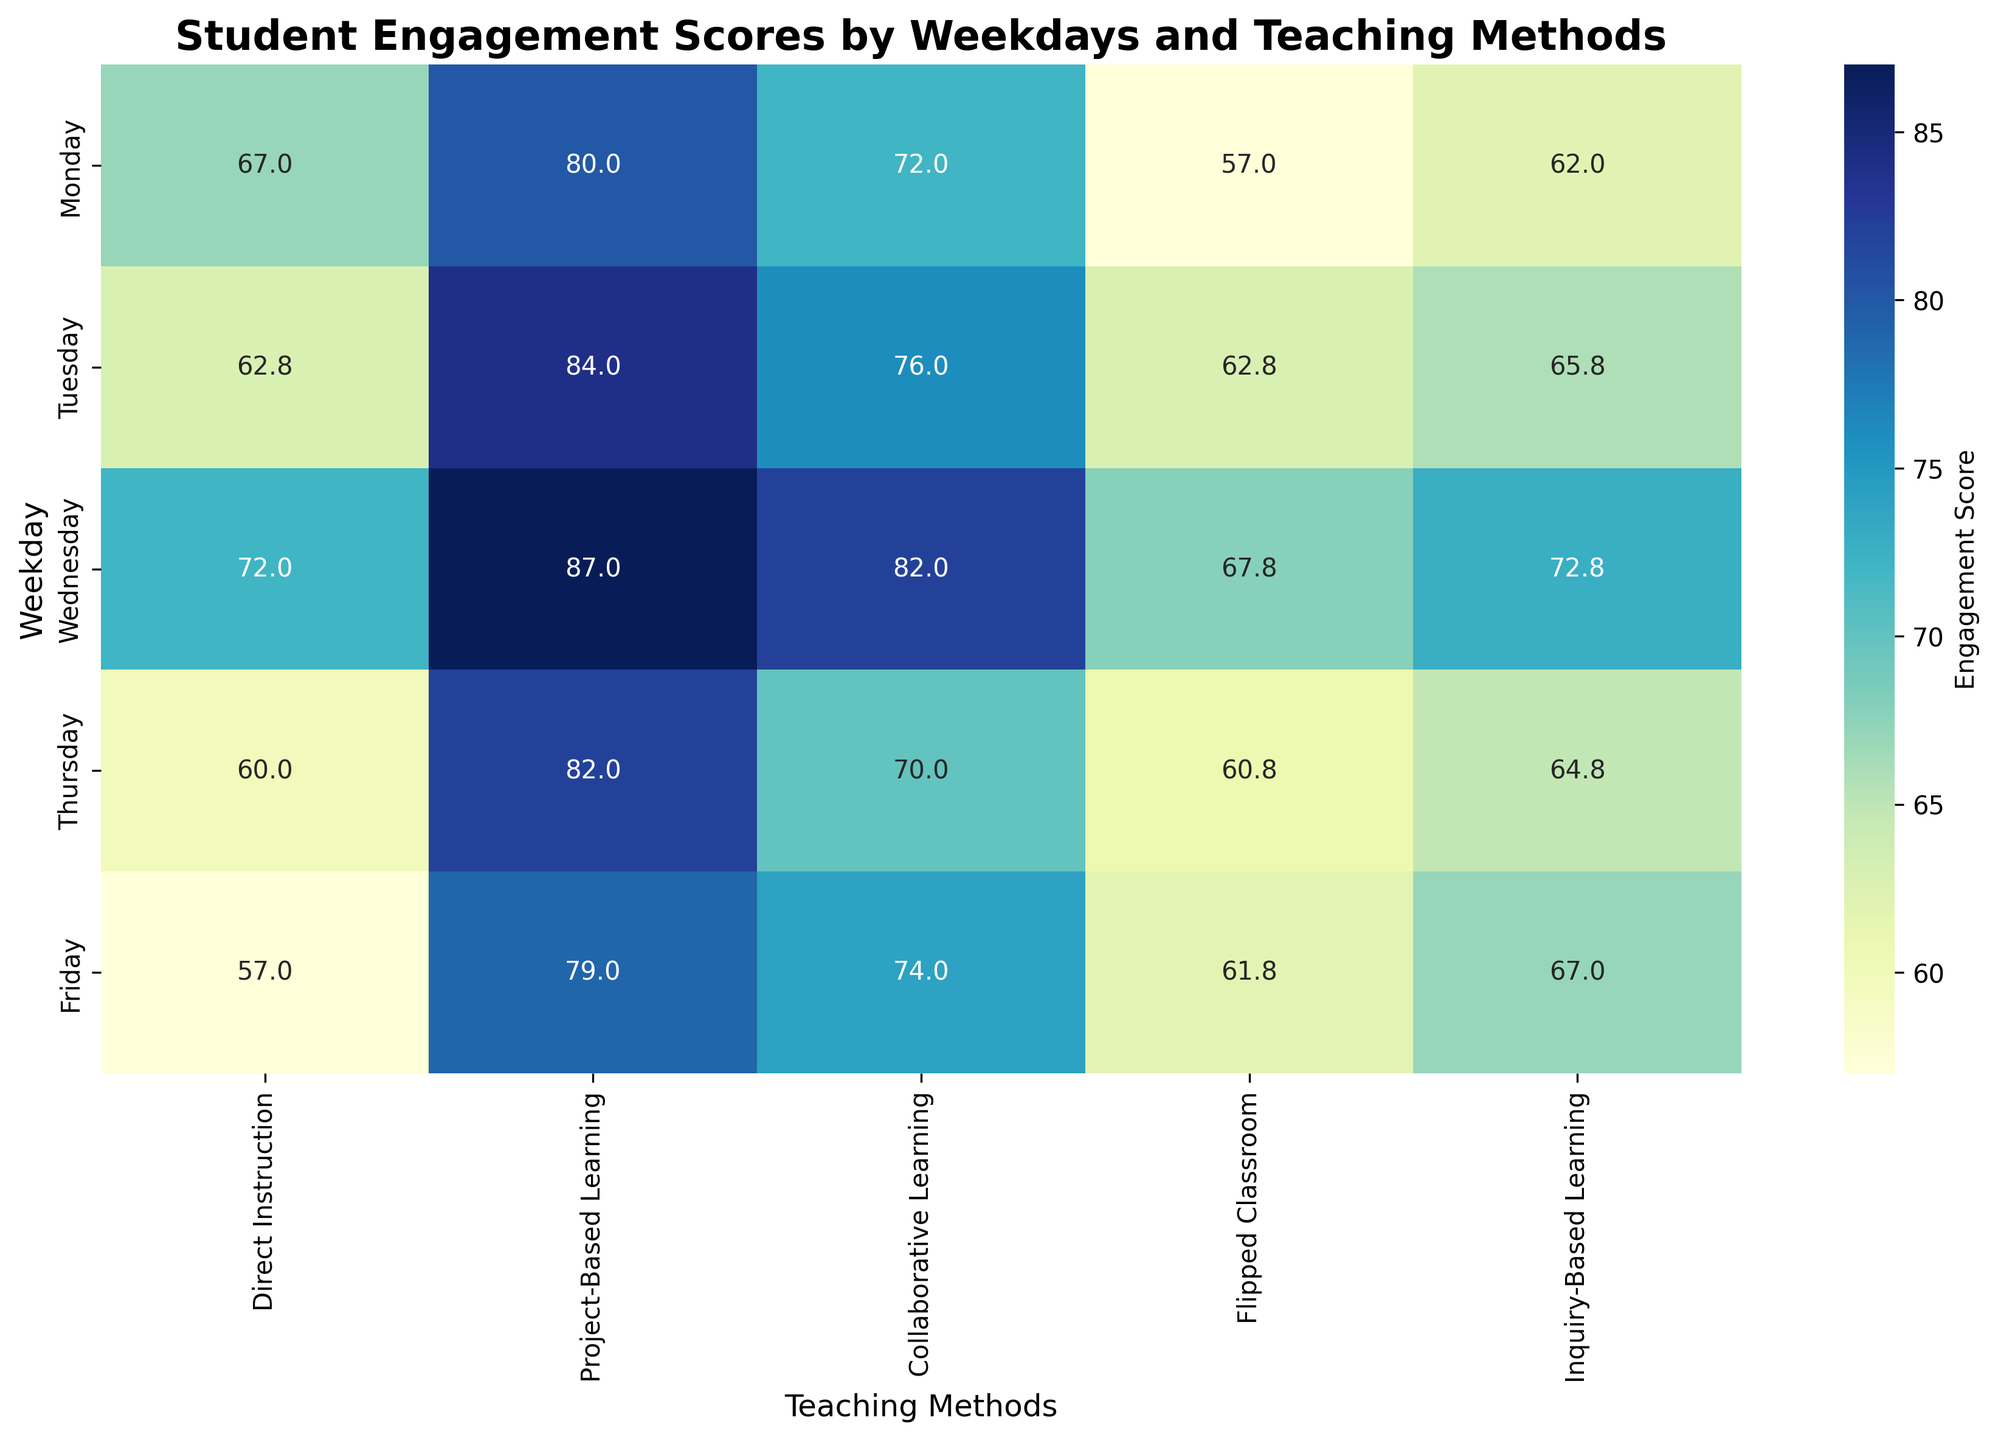Is there a particular weekday when students engage the most across all teaching methods combined? To find the weekday with the highest engagement scores across all teaching methods, observe the heatmap for the weekday with the highest overall shades. Wednesday consistently has the darkest shades, indicating the highest scores.
Answer: Wednesday How does the engagement score for Project-Based Learning change from Monday to Friday? Track the cells corresponding to Project-Based Learning from Monday to Friday. The scores are 78 (Monday), 82 (Tuesday), 85 (Wednesday), 80 (Thursday), and 77 (Friday).
Answer: It slightly decreases from 78 on Monday to 77 on Friday Which teaching method shows the most consistent student engagement throughout the week? To determine consistency, look for the teaching method with the least variation in shades across the weekdays. Direct Instruction and Flipped Classroom seem consistent but Direct Instruction has less variation.
Answer: Direct Instruction On which day is the engagement for Inquiry-Based Learning the lowest, and what is that score? Find the lightest shade in the Inquiry-Based Learning column. The score is lowest on Monday, with a value of 60.
Answer: Monday, score 60 Compare the engagement scores of Flipped Classroom and Collaborative Learning on Wednesdays. Which is higher and by how much? Look at the scores for Wednesday in the columns for Flipped Classroom and Collaborative Learning. The scores are 70 (Collaborative Learning) and 65 (Flipped Classroom). The difference is 5.
Answer: Collaborative Learning is higher by 5 Is there any weekday when the engagement for Project-Based Learning is above 80 but below for Inquiry-Based Learning? On Tuesday and Wednesday, Project-Based Learning scores above 80 (82 and 85), whereas Inquiry-Based Learning scores below 80 (63 and 70).
Answer: Yes, Tuesday and Wednesday Which teaching method shows the greatest increase in student engagement from Monday to Wednesday? Observe the scores for each method from Monday to Wednesday and calculate the increases. Flipped Classroom has the highest increase from 55 (Monday) to 65 (Wednesday), a difference of 10.
Answer: Flipped Classroom How does student engagement for Direct Instruction on Tuesday compare to that for Inquiry-Based Learning on Thursday? Look at the respective scores: 60 (Direct Instruction on Tuesday) and 62 (Inquiry-Based Learning on Thursday). Both scores are close, but Inquiry-Based Learning on Thursday is slightly higher.
Answer: Inquiry-Based Learning on Thursday is higher by 2 What is the average student engagement score for Collaborative Learning on Mondays? Take the scores for Collaborative Learning on each Monday: 70, 73, 71, 72, and 74. Calculate the average by summing these values (70+73+71+72+74 = 360) and dividing by 5.
Answer: 72 